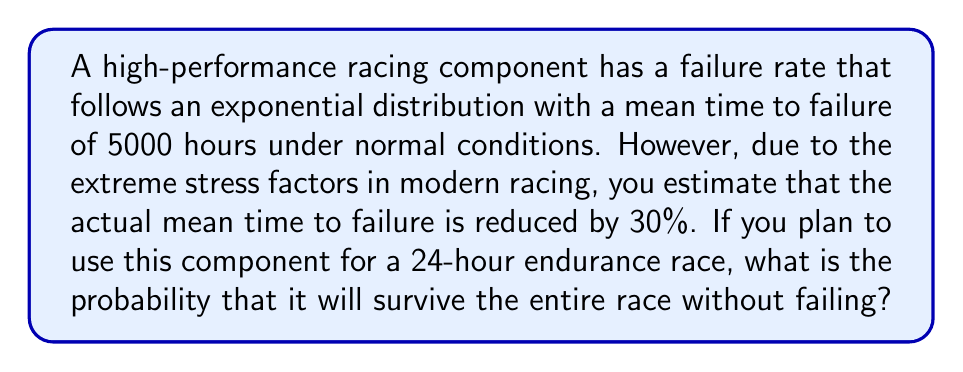What is the answer to this math problem? Let's approach this problem step-by-step:

1) First, we need to calculate the adjusted mean time to failure under racing conditions:
   
   $$\text{Adjusted Mean} = 5000 \text{ hours} \times (1 - 0.30) = 3500 \text{ hours}$$

2) For an exponential distribution, the probability of survival (reliability) up to time $t$ is given by:

   $$R(t) = e^{-\lambda t}$$

   where $\lambda$ is the failure rate (inverse of the mean time to failure).

3) Calculate $\lambda$:
   
   $$\lambda = \frac{1}{\text{Adjusted Mean}} = \frac{1}{3500} \approx 0.0002857 \text{ per hour}$$

4) Now, we can calculate the probability of survival for a 24-hour race:

   $$R(24) = e^{-\lambda \times 24} = e^{-0.0002857 \times 24} \approx e^{-0.006857}$$

5) Using a calculator or computer to evaluate this exponential:

   $$R(24) \approx 0.9932$$

Therefore, the probability that the component will survive the entire 24-hour race without failing is approximately 0.9932 or 99.32%.
Answer: The probability that the racing component will survive the entire 24-hour race without failing is approximately 0.9932 or 99.32%. 